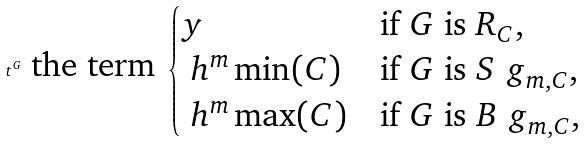Convert formula to latex. <formula><loc_0><loc_0><loc_500><loc_500>t ^ { G } \text { the term } \begin{cases} y & \text {if } G \text { is } R _ { C } , \\ \ h ^ { m } \min ( C ) & \text {if } G \text { is } S ^ { \ } g _ { m , C } , \\ \ h ^ { m } \max ( C ) & \text {if } G \text { is    } B ^ { \ } g _ { m , C } , \end{cases}</formula> 